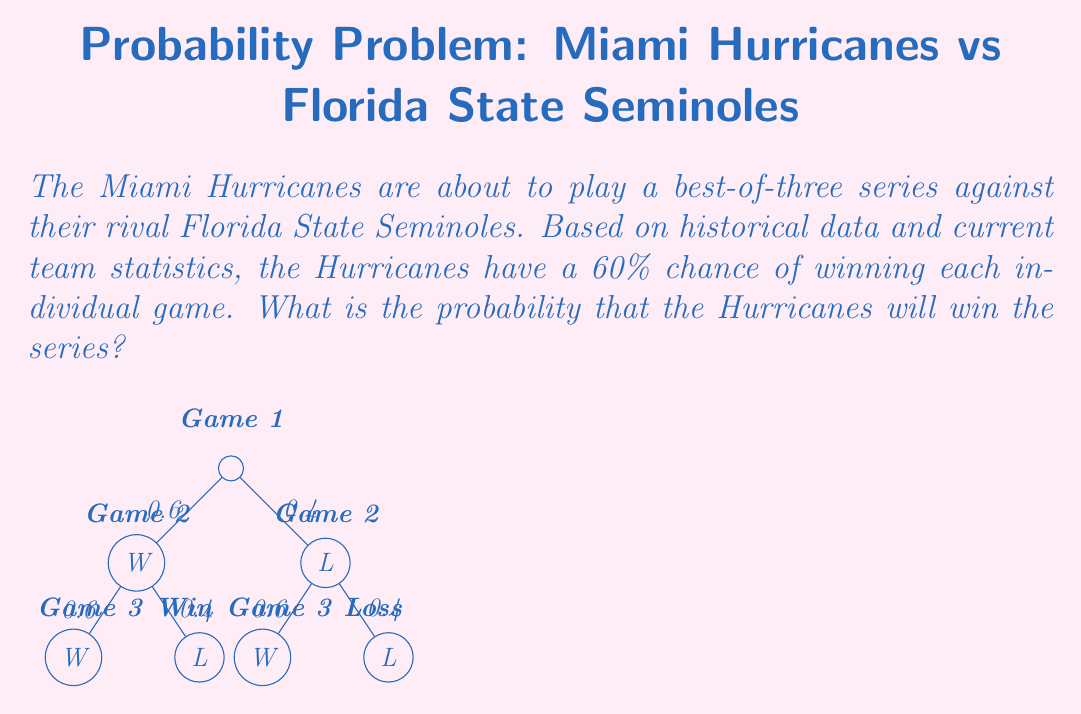Teach me how to tackle this problem. Let's approach this step-by-step:

1) The Hurricanes can win the series in two ways:
   a) Winning the first two games
   b) Winning the first and third games, or the second and third games

2) Let's calculate the probability of each scenario:

   a) Winning first two games:
      $P(\text{Win first two}) = 0.6 \times 0.6 = 0.36$

   b) Winning first and third games (losing second):
      $P(\text{Win 1st, lose 2nd, win 3rd}) = 0.6 \times 0.4 \times 0.6 = 0.144$

   c) Losing first game, winning second and third:
      $P(\text{Lose 1st, win 2nd, win 3rd}) = 0.4 \times 0.6 \times 0.6 = 0.144$

3) The total probability of winning the series is the sum of these probabilities:

   $$P(\text{Win series}) = 0.36 + 0.144 + 0.144 = 0.648$$

4) We can verify this using the complement probability:
   
   $P(\text{Lose series}) = P(\text{Lose first two}) + P(\text{Lose two out of three})$
   $= 0.4 \times 0.4 + (0.6 \times 0.4 \times 0.4 + 0.4 \times 0.6 \times 0.4)$
   $= 0.16 + 0.192 = 0.352$

   $P(\text{Win series}) = 1 - P(\text{Lose series}) = 1 - 0.352 = 0.648$

Therefore, the probability that the Miami Hurricanes will win the series is 0.648 or 64.8%.
Answer: 0.648 or 64.8% 